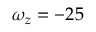<formula> <loc_0><loc_0><loc_500><loc_500>\omega _ { z } = - 2 5</formula> 